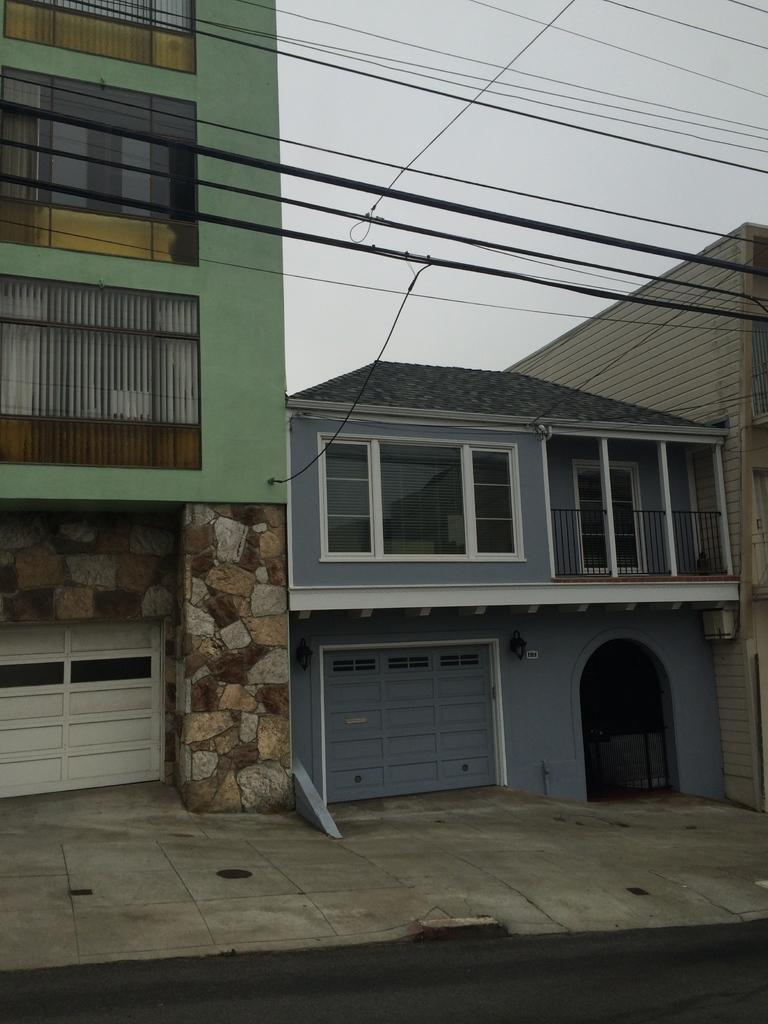What type of structures are present in the image? There are buildings in the image. What feature do the buildings have? The buildings have windows. What can be seen at the bottom of the image? There are gates at the bottom of the image. What is present at the top of the image? There are wires at the top of the image. What is visible in the background of the image? The sky is visible in the image. What is the texture of the table in the image? There is no table present in the image. 